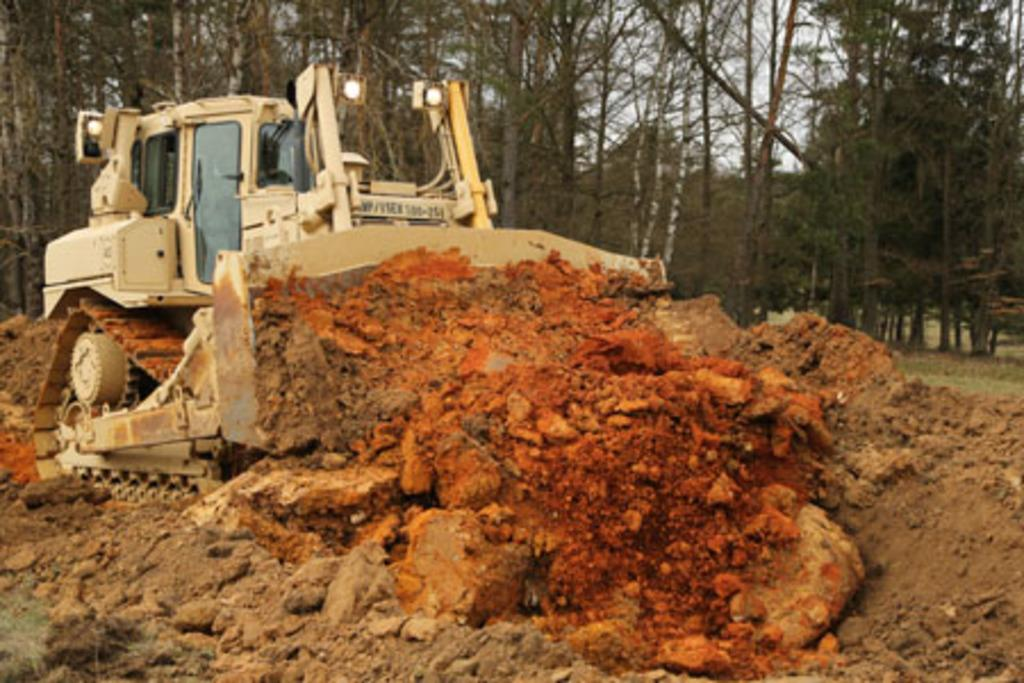What is the main subject of the image? The main subject of the image is a bulldozer. What is the bulldozer doing in the image? The bulldozer is carrying mud in the image. What can be seen in the background of the image? There are trees in the background of the image. What type of lock is holding the bulldozer in place in the image? There is no lock present in the image; the bulldozer is not stationary but is carrying mud. 